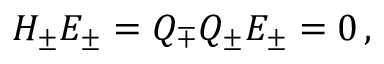Convert formula to latex. <formula><loc_0><loc_0><loc_500><loc_500>H _ { \pm } E _ { \pm } = Q _ { \mp } Q _ { \pm } E _ { \pm } = 0 \, ,</formula> 